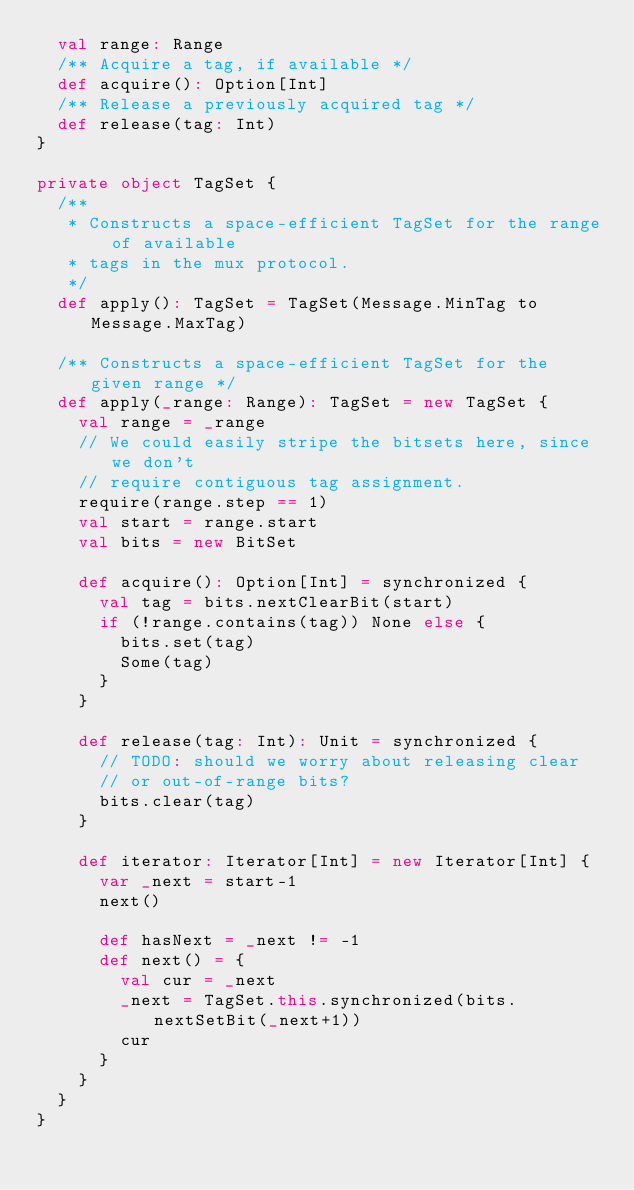<code> <loc_0><loc_0><loc_500><loc_500><_Scala_>  val range: Range
  /** Acquire a tag, if available */
  def acquire(): Option[Int]
  /** Release a previously acquired tag */
  def release(tag: Int)
}

private object TagSet {
  /**
   * Constructs a space-efficient TagSet for the range of available
   * tags in the mux protocol.
   */
  def apply(): TagSet = TagSet(Message.MinTag to Message.MaxTag)

  /** Constructs a space-efficient TagSet for the given range */
  def apply(_range: Range): TagSet = new TagSet {
    val range = _range
    // We could easily stripe the bitsets here, since we don't
    // require contiguous tag assignment.
    require(range.step == 1)
    val start = range.start
    val bits = new BitSet

    def acquire(): Option[Int] = synchronized {
      val tag = bits.nextClearBit(start)
      if (!range.contains(tag)) None else {
        bits.set(tag)
        Some(tag)
      }
    }

    def release(tag: Int): Unit = synchronized {
      // TODO: should we worry about releasing clear
      // or out-of-range bits?
      bits.clear(tag)
    }

    def iterator: Iterator[Int] = new Iterator[Int] {
      var _next = start-1
      next()

      def hasNext = _next != -1
      def next() = {
        val cur = _next
        _next = TagSet.this.synchronized(bits.nextSetBit(_next+1))
        cur
      }
    }
  }
}
</code> 